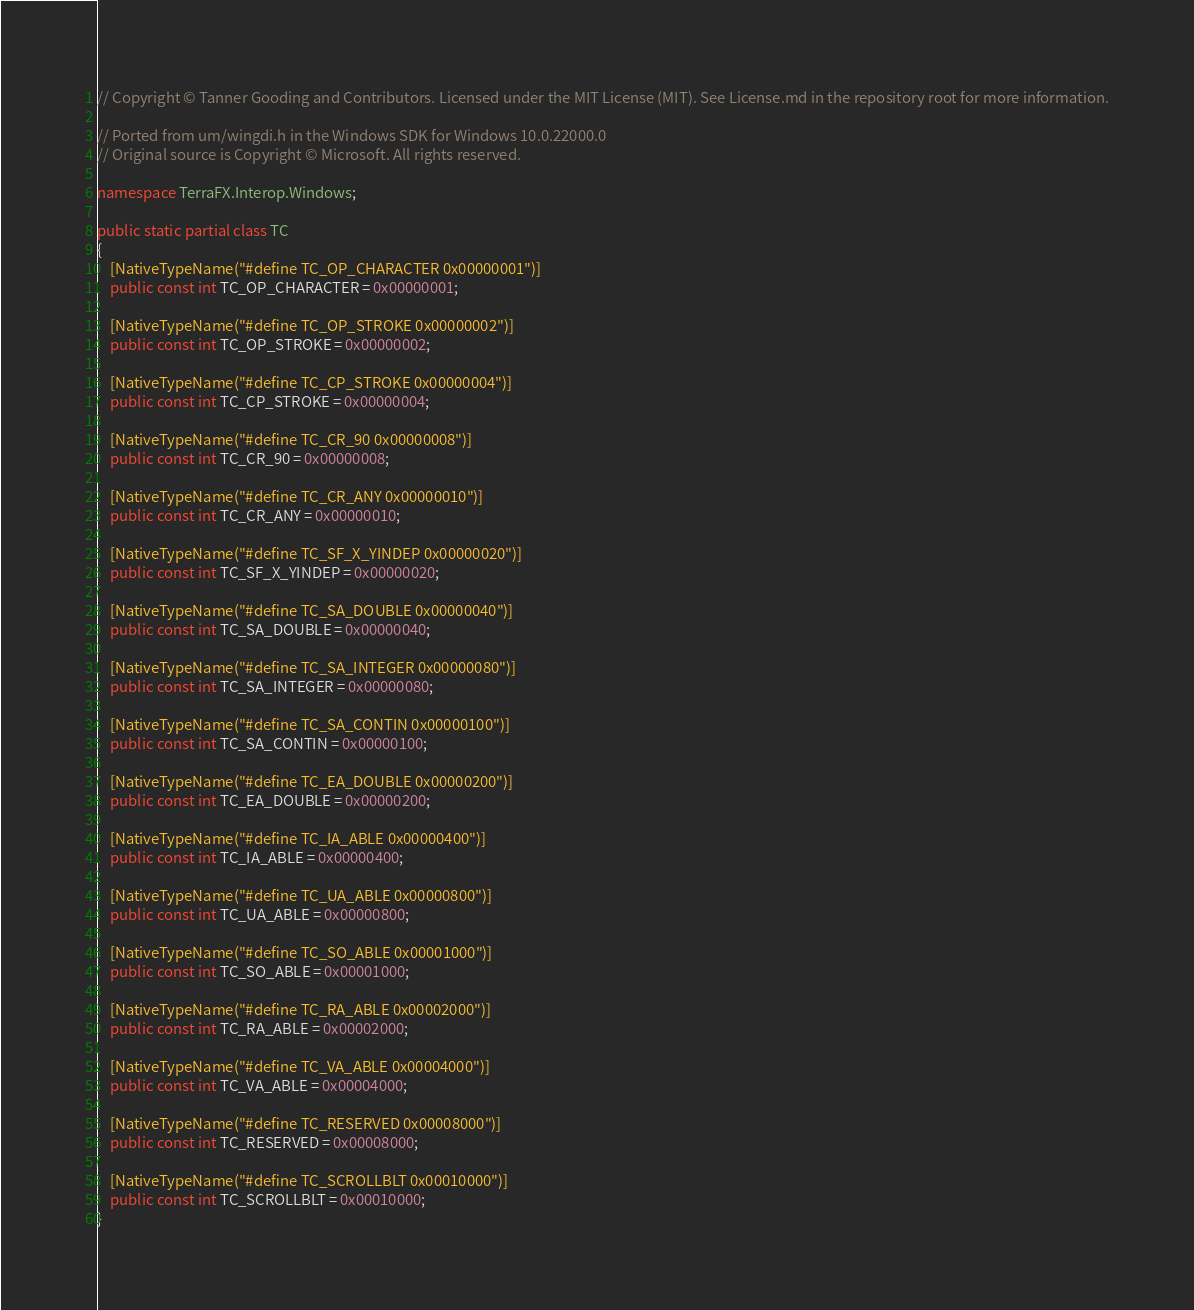<code> <loc_0><loc_0><loc_500><loc_500><_C#_>// Copyright © Tanner Gooding and Contributors. Licensed under the MIT License (MIT). See License.md in the repository root for more information.

// Ported from um/wingdi.h in the Windows SDK for Windows 10.0.22000.0
// Original source is Copyright © Microsoft. All rights reserved.

namespace TerraFX.Interop.Windows;

public static partial class TC
{
    [NativeTypeName("#define TC_OP_CHARACTER 0x00000001")]
    public const int TC_OP_CHARACTER = 0x00000001;

    [NativeTypeName("#define TC_OP_STROKE 0x00000002")]
    public const int TC_OP_STROKE = 0x00000002;

    [NativeTypeName("#define TC_CP_STROKE 0x00000004")]
    public const int TC_CP_STROKE = 0x00000004;

    [NativeTypeName("#define TC_CR_90 0x00000008")]
    public const int TC_CR_90 = 0x00000008;

    [NativeTypeName("#define TC_CR_ANY 0x00000010")]
    public const int TC_CR_ANY = 0x00000010;

    [NativeTypeName("#define TC_SF_X_YINDEP 0x00000020")]
    public const int TC_SF_X_YINDEP = 0x00000020;

    [NativeTypeName("#define TC_SA_DOUBLE 0x00000040")]
    public const int TC_SA_DOUBLE = 0x00000040;

    [NativeTypeName("#define TC_SA_INTEGER 0x00000080")]
    public const int TC_SA_INTEGER = 0x00000080;

    [NativeTypeName("#define TC_SA_CONTIN 0x00000100")]
    public const int TC_SA_CONTIN = 0x00000100;

    [NativeTypeName("#define TC_EA_DOUBLE 0x00000200")]
    public const int TC_EA_DOUBLE = 0x00000200;

    [NativeTypeName("#define TC_IA_ABLE 0x00000400")]
    public const int TC_IA_ABLE = 0x00000400;

    [NativeTypeName("#define TC_UA_ABLE 0x00000800")]
    public const int TC_UA_ABLE = 0x00000800;

    [NativeTypeName("#define TC_SO_ABLE 0x00001000")]
    public const int TC_SO_ABLE = 0x00001000;

    [NativeTypeName("#define TC_RA_ABLE 0x00002000")]
    public const int TC_RA_ABLE = 0x00002000;

    [NativeTypeName("#define TC_VA_ABLE 0x00004000")]
    public const int TC_VA_ABLE = 0x00004000;

    [NativeTypeName("#define TC_RESERVED 0x00008000")]
    public const int TC_RESERVED = 0x00008000;

    [NativeTypeName("#define TC_SCROLLBLT 0x00010000")]
    public const int TC_SCROLLBLT = 0x00010000;
}
</code> 